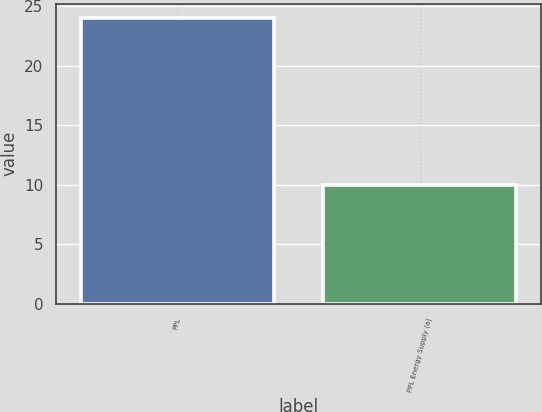Convert chart. <chart><loc_0><loc_0><loc_500><loc_500><bar_chart><fcel>PPL<fcel>PPL Energy Supply (a)<nl><fcel>24<fcel>10<nl></chart> 